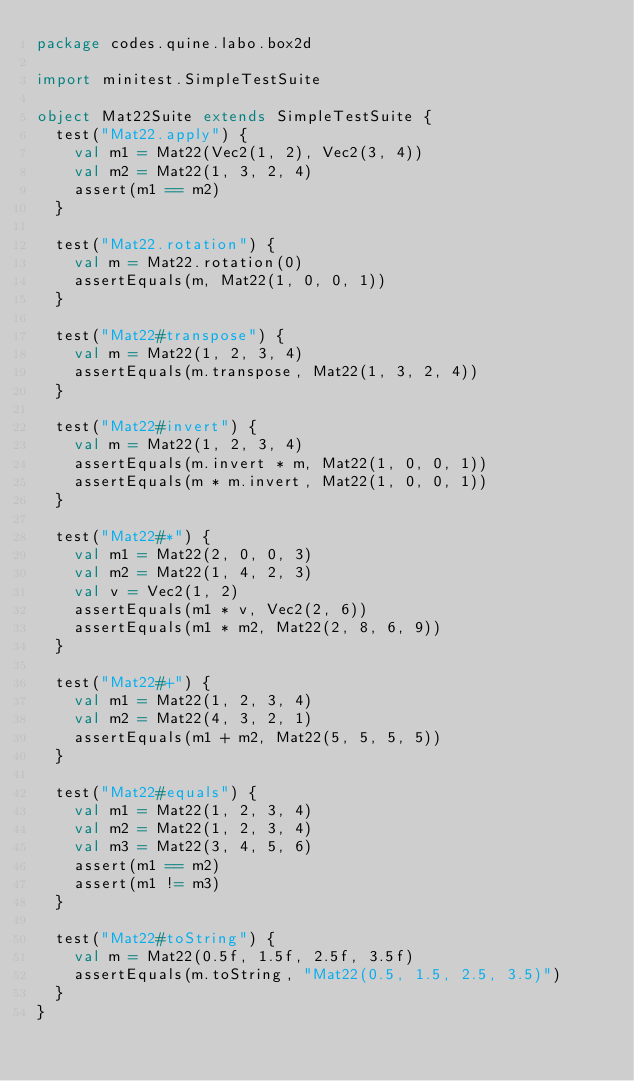Convert code to text. <code><loc_0><loc_0><loc_500><loc_500><_Scala_>package codes.quine.labo.box2d

import minitest.SimpleTestSuite

object Mat22Suite extends SimpleTestSuite {
  test("Mat22.apply") {
    val m1 = Mat22(Vec2(1, 2), Vec2(3, 4))
    val m2 = Mat22(1, 3, 2, 4)
    assert(m1 == m2)
  }

  test("Mat22.rotation") {
    val m = Mat22.rotation(0)
    assertEquals(m, Mat22(1, 0, 0, 1))
  }

  test("Mat22#transpose") {
    val m = Mat22(1, 2, 3, 4)
    assertEquals(m.transpose, Mat22(1, 3, 2, 4))
  }

  test("Mat22#invert") {
    val m = Mat22(1, 2, 3, 4)
    assertEquals(m.invert * m, Mat22(1, 0, 0, 1))
    assertEquals(m * m.invert, Mat22(1, 0, 0, 1))
  }

  test("Mat22#*") {
    val m1 = Mat22(2, 0, 0, 3)
    val m2 = Mat22(1, 4, 2, 3)
    val v = Vec2(1, 2)
    assertEquals(m1 * v, Vec2(2, 6))
    assertEquals(m1 * m2, Mat22(2, 8, 6, 9))
  }

  test("Mat22#+") {
    val m1 = Mat22(1, 2, 3, 4)
    val m2 = Mat22(4, 3, 2, 1)
    assertEquals(m1 + m2, Mat22(5, 5, 5, 5))
  }

  test("Mat22#equals") {
    val m1 = Mat22(1, 2, 3, 4)
    val m2 = Mat22(1, 2, 3, 4)
    val m3 = Mat22(3, 4, 5, 6)
    assert(m1 == m2)
    assert(m1 != m3)
  }

  test("Mat22#toString") {
    val m = Mat22(0.5f, 1.5f, 2.5f, 3.5f)
    assertEquals(m.toString, "Mat22(0.5, 1.5, 2.5, 3.5)")
  }
}
</code> 